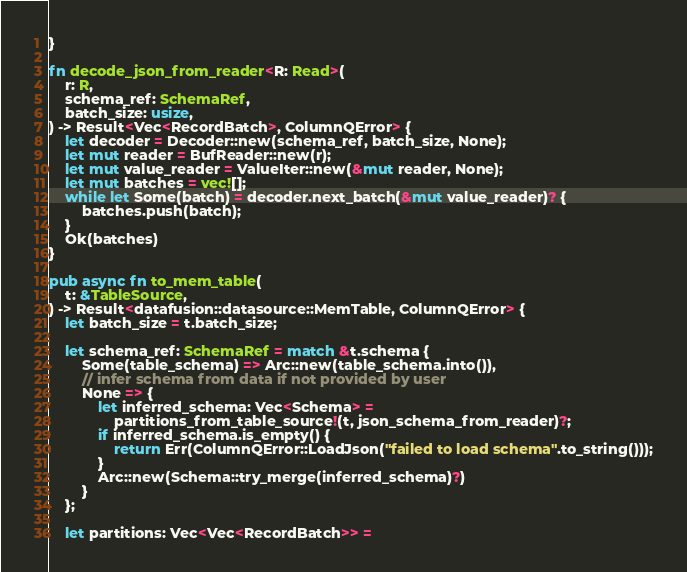Convert code to text. <code><loc_0><loc_0><loc_500><loc_500><_Rust_>}

fn decode_json_from_reader<R: Read>(
    r: R,
    schema_ref: SchemaRef,
    batch_size: usize,
) -> Result<Vec<RecordBatch>, ColumnQError> {
    let decoder = Decoder::new(schema_ref, batch_size, None);
    let mut reader = BufReader::new(r);
    let mut value_reader = ValueIter::new(&mut reader, None);
    let mut batches = vec![];
    while let Some(batch) = decoder.next_batch(&mut value_reader)? {
        batches.push(batch);
    }
    Ok(batches)
}

pub async fn to_mem_table(
    t: &TableSource,
) -> Result<datafusion::datasource::MemTable, ColumnQError> {
    let batch_size = t.batch_size;

    let schema_ref: SchemaRef = match &t.schema {
        Some(table_schema) => Arc::new(table_schema.into()),
        // infer schema from data if not provided by user
        None => {
            let inferred_schema: Vec<Schema> =
                partitions_from_table_source!(t, json_schema_from_reader)?;
            if inferred_schema.is_empty() {
                return Err(ColumnQError::LoadJson("failed to load schema".to_string()));
            }
            Arc::new(Schema::try_merge(inferred_schema)?)
        }
    };

    let partitions: Vec<Vec<RecordBatch>> =</code> 